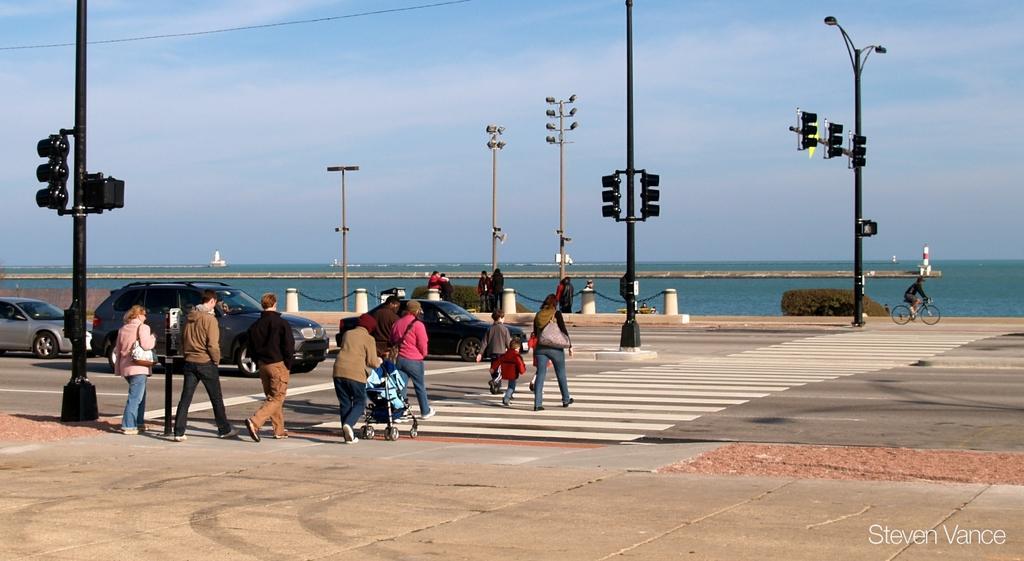Please provide a concise description of this image. This is an outside view. At the bottom there is a road. On the left side there are few cars and also I can see few people are crossing the road. On both sides of the road there are few traffic signal poles. On the right side there is a person riding the bicycle. In the background there is a sea. At the top of the image I can see the sky. 